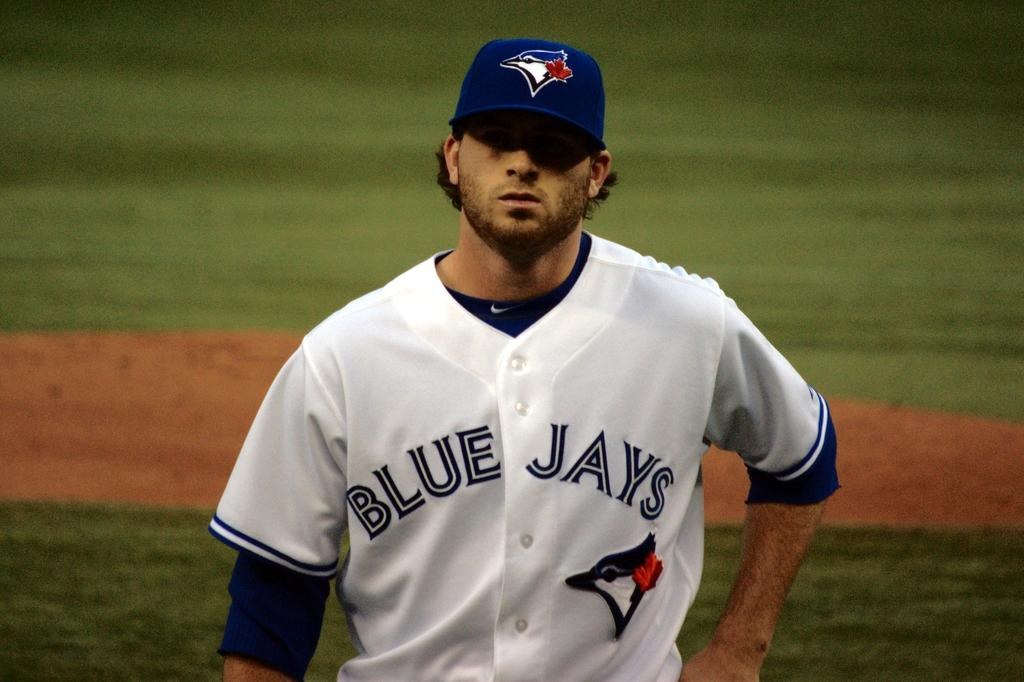<image>
Summarize the visual content of the image. a man with a Blue Jays jersey on at a baseball stadium 